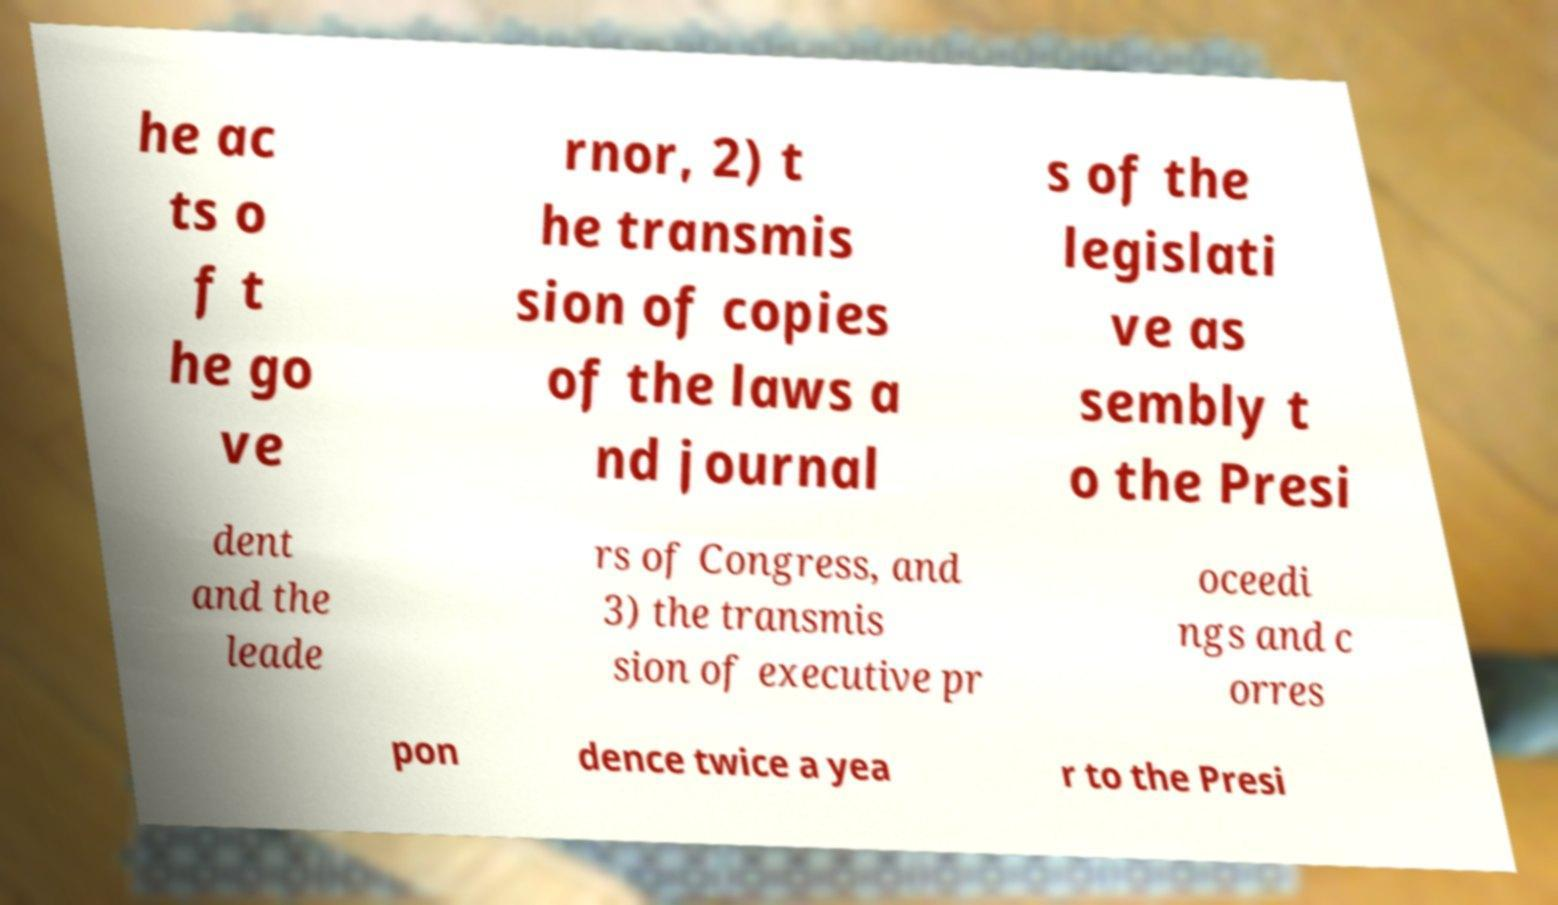Please read and relay the text visible in this image. What does it say? he ac ts o f t he go ve rnor, 2) t he transmis sion of copies of the laws a nd journal s of the legislati ve as sembly t o the Presi dent and the leade rs of Congress, and 3) the transmis sion of executive pr oceedi ngs and c orres pon dence twice a yea r to the Presi 